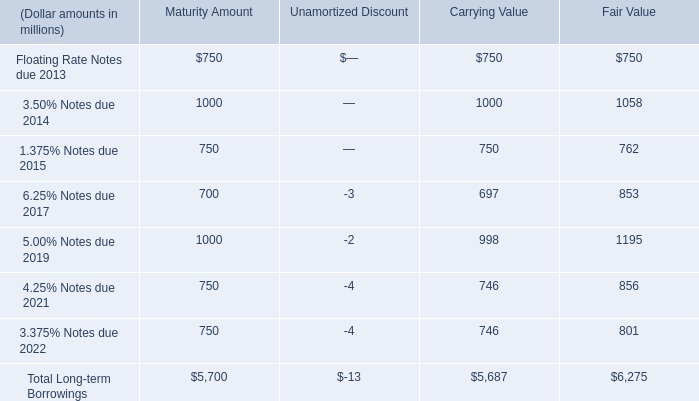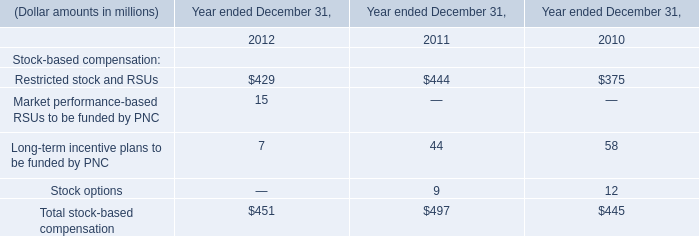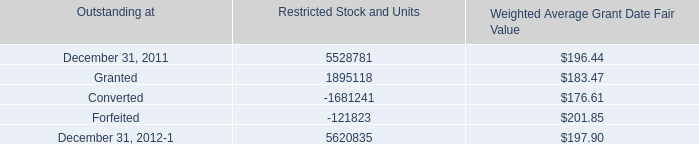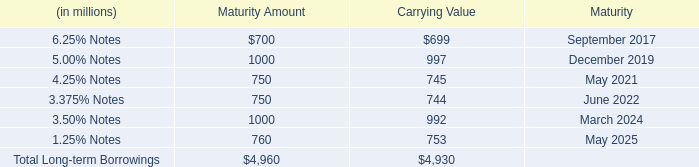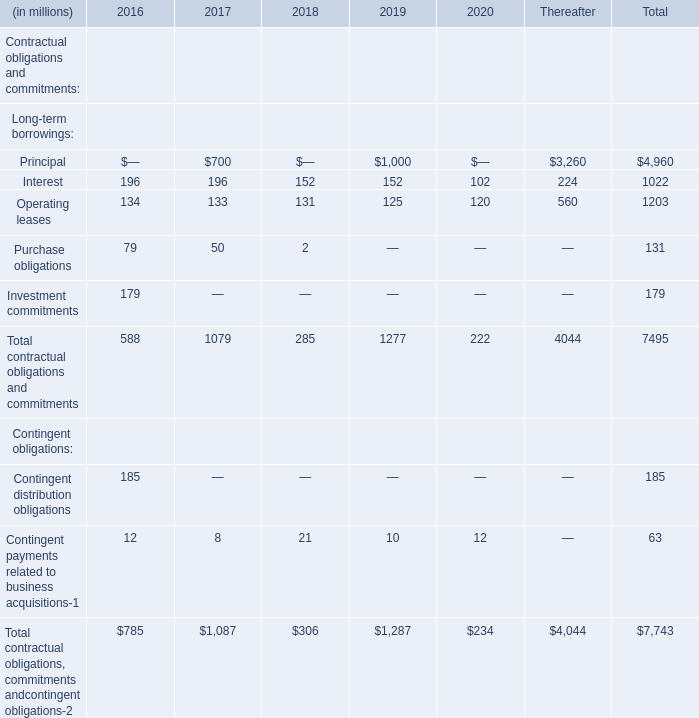what portion of the total long-term borrowings is due in the next 24 months? 
Computations: ((750 + 1000) / 5700)
Answer: 0.30702. 